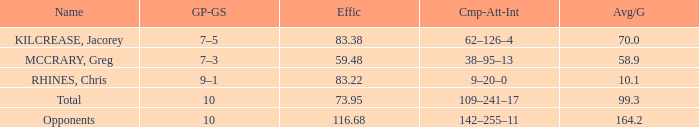9 avg/g? 59.48. 